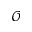Convert formula to latex. <formula><loc_0><loc_0><loc_500><loc_500>\mathcal { O }</formula> 